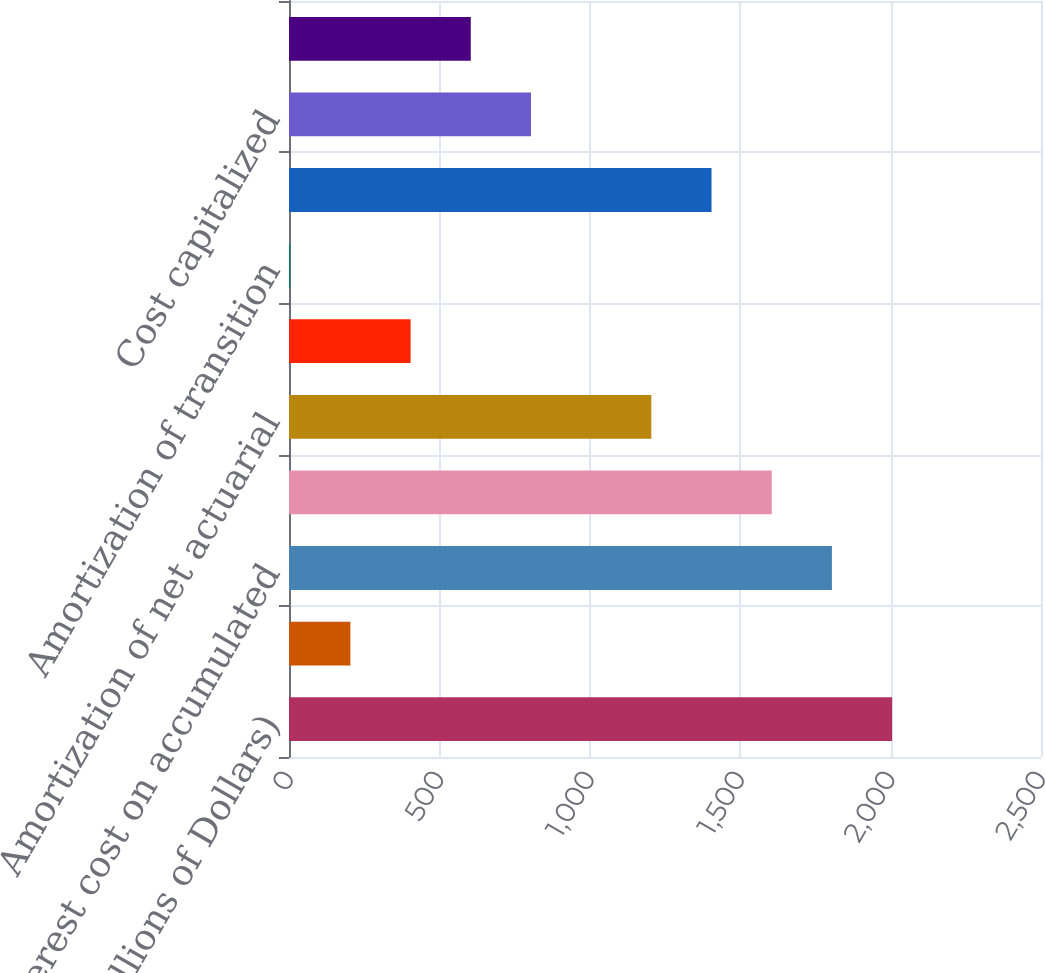Convert chart. <chart><loc_0><loc_0><loc_500><loc_500><bar_chart><fcel>(Millions of Dollars)<fcel>Service cost<fcel>Interest cost on accumulated<fcel>Expected return on plan assets<fcel>Amortization of net actuarial<fcel>Amortization of prior service<fcel>Amortization of transition<fcel>Net Periodic Postretirement<fcel>Cost capitalized<fcel>Cost deferred<nl><fcel>2005<fcel>204.1<fcel>1804.9<fcel>1604.8<fcel>1204.6<fcel>404.2<fcel>4<fcel>1404.7<fcel>804.4<fcel>604.3<nl></chart> 